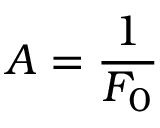Convert formula to latex. <formula><loc_0><loc_0><loc_500><loc_500>A = \frac { 1 } { F _ { 0 } }</formula> 